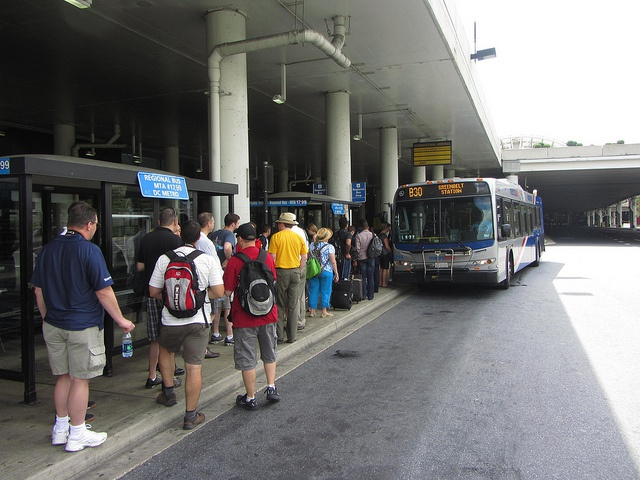Describe the objects in this image and their specific colors. I can see bus in black, gray, darkgray, and lightgray tones, people in black, gray, navy, and darkgray tones, people in black, gray, and lightgray tones, people in black, gray, maroon, and darkgray tones, and people in black, gray, and orange tones in this image. 